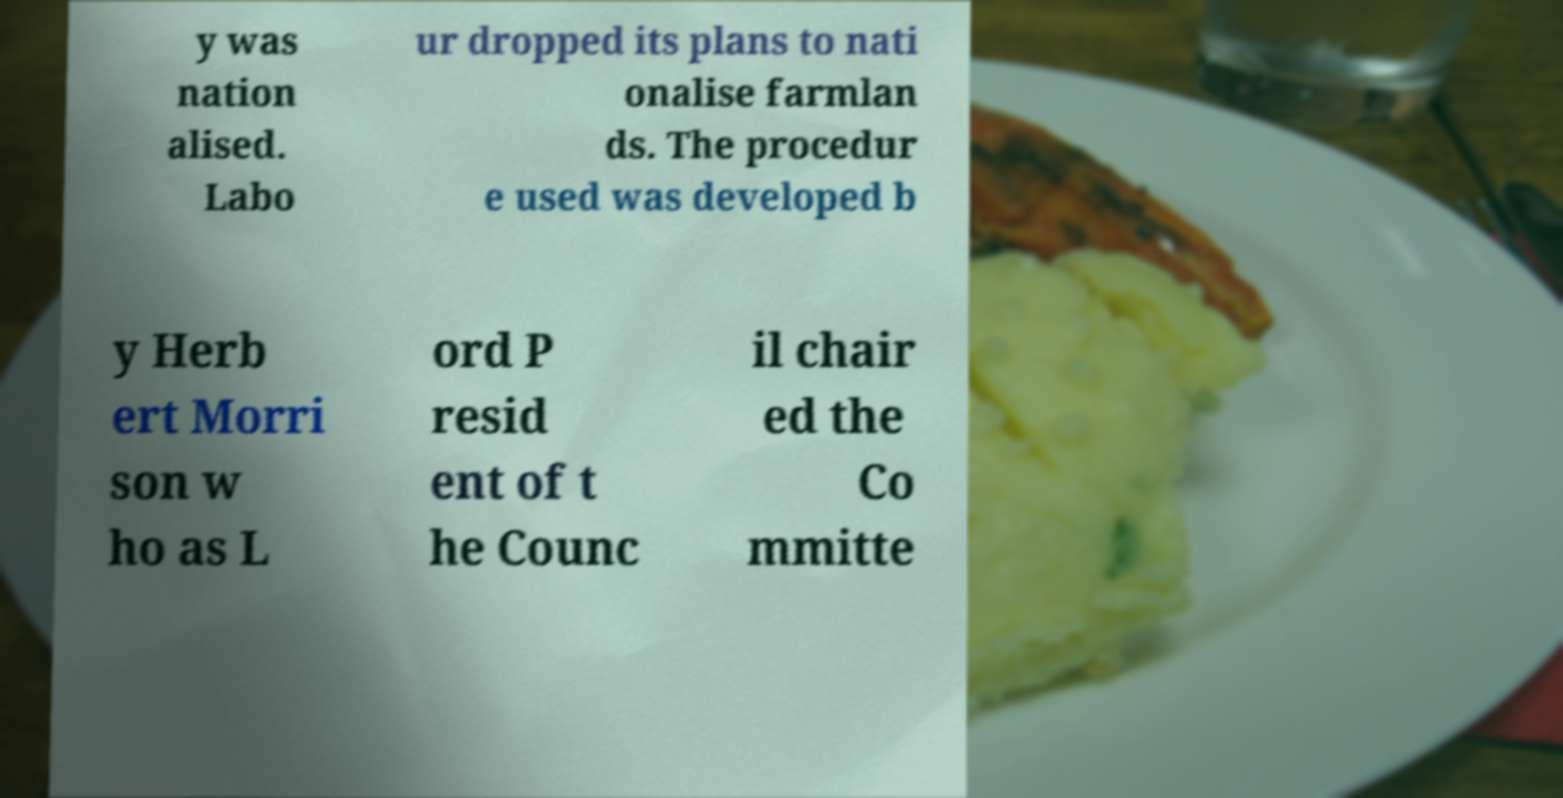Please identify and transcribe the text found in this image. y was nation alised. Labo ur dropped its plans to nati onalise farmlan ds. The procedur e used was developed b y Herb ert Morri son w ho as L ord P resid ent of t he Counc il chair ed the Co mmitte 